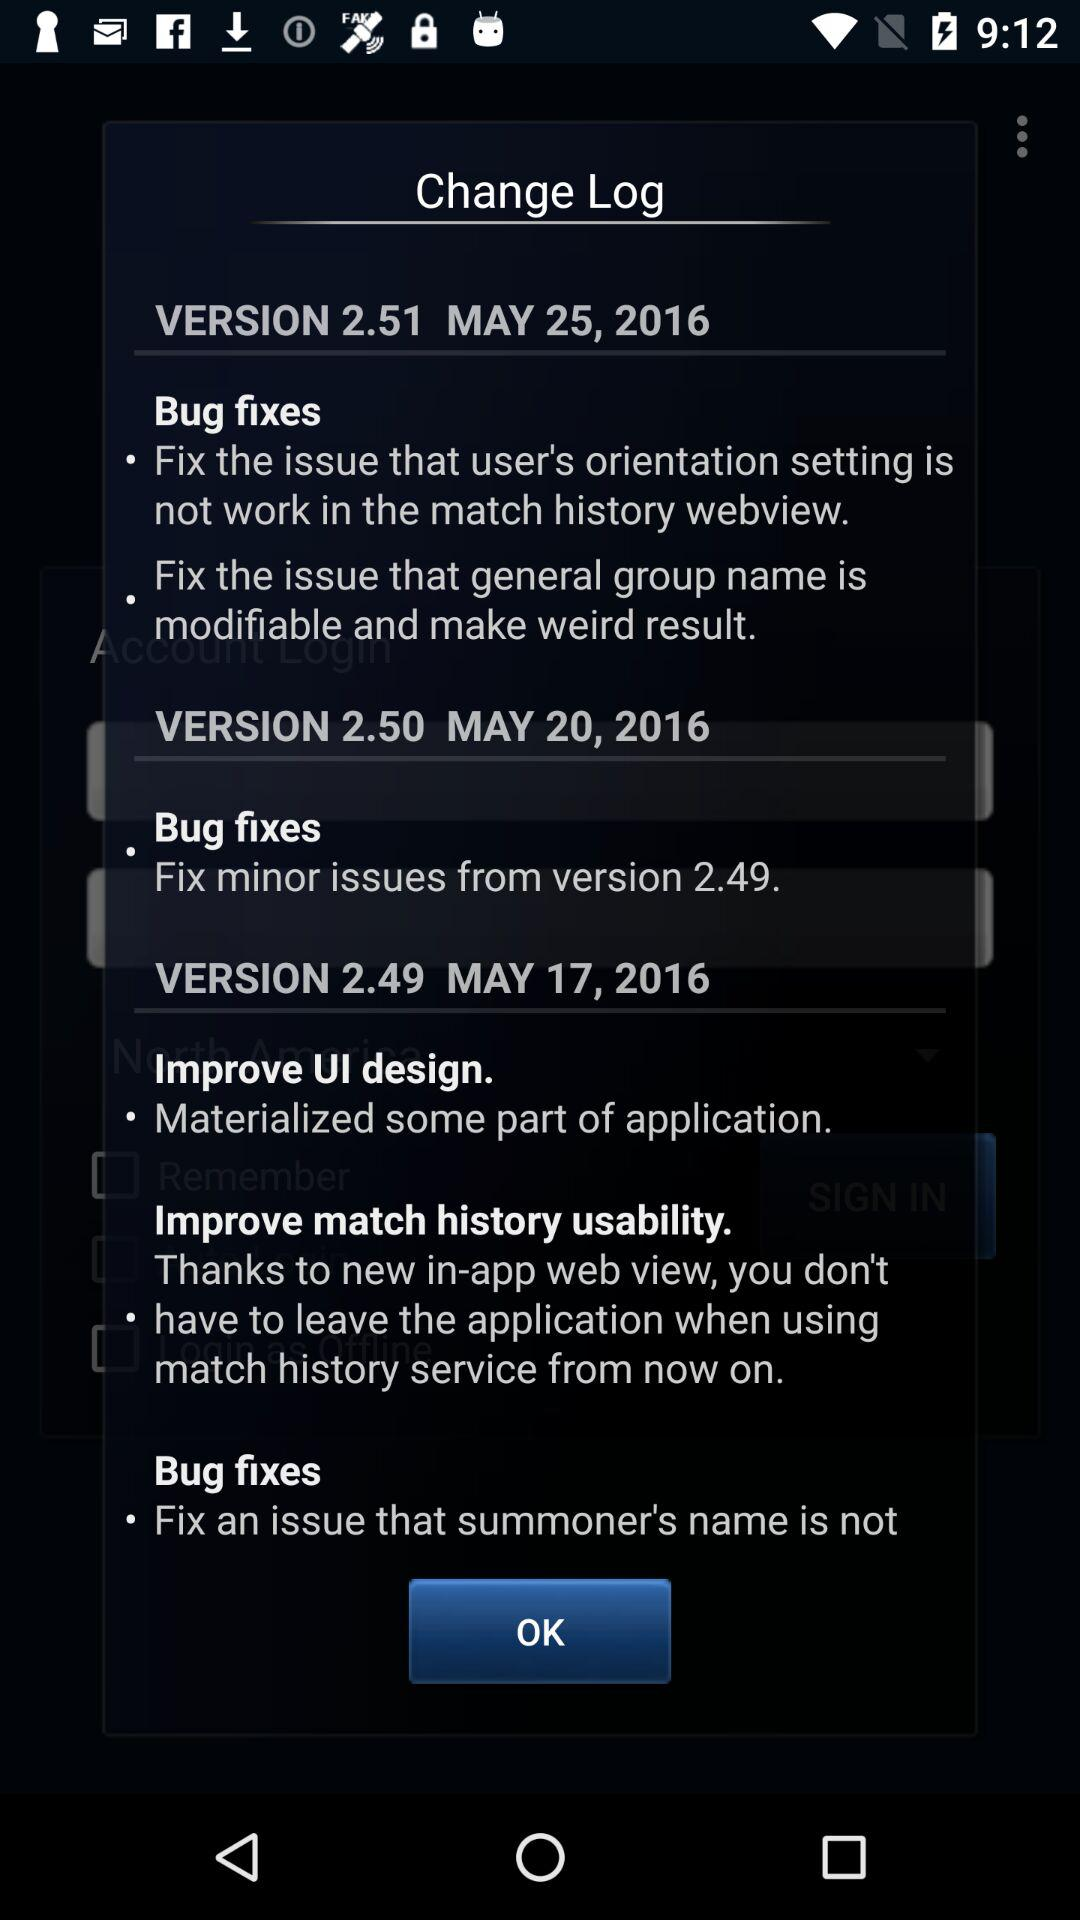Version 2.49 was updated on which date? The date was May 17, 2016. 